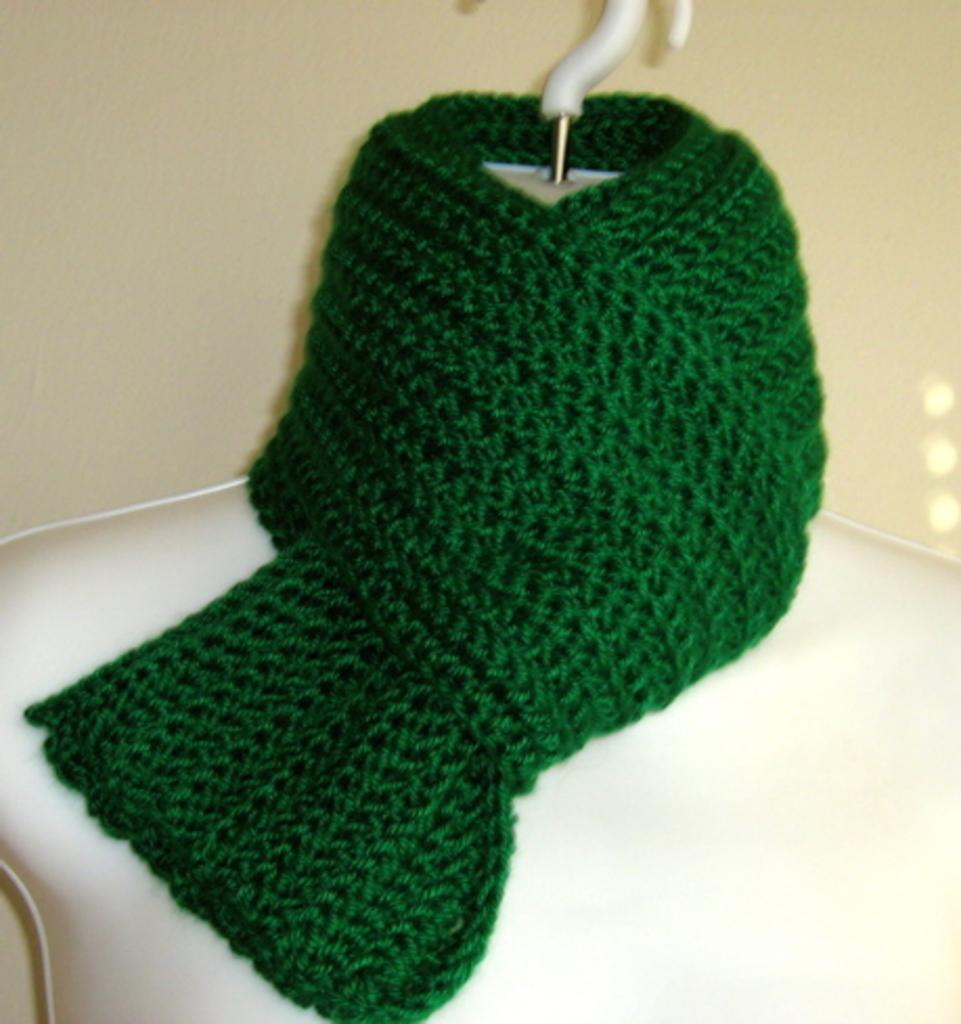What is located in the center of the image? There is a manikin and a scarf in the center of the image. Can you describe the manikin in the image? The manikin is in the center of the image. What is visible in the background of the image? There is a wall in the background of the image. How many slaves are visible in the image? There are no slaves present in the image. What type of material is the truck made of in the image? There is no truck present in the image. 